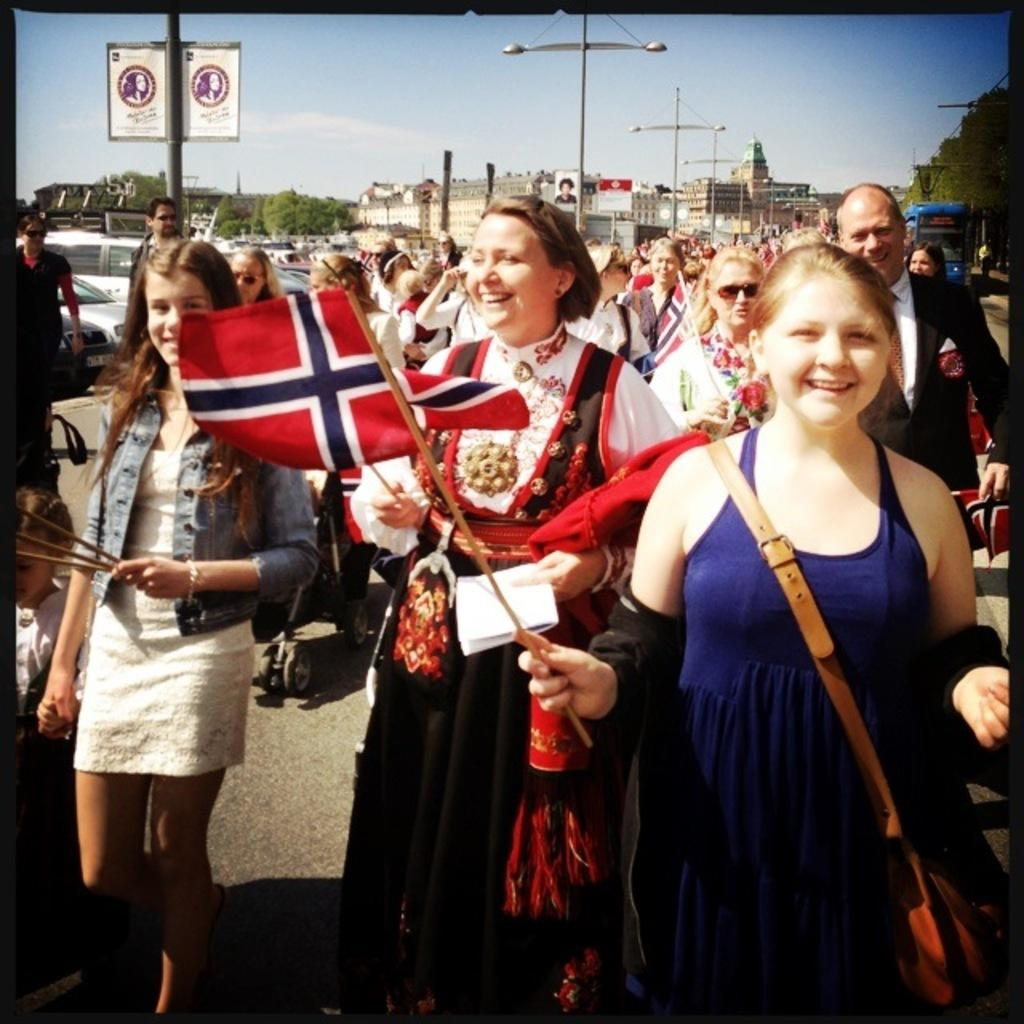What are the people in the image doing? The people in the image are standing on a road and holding flags. What else are the people holding in their hands? The people are also holding paper in their hands. What can be seen in the background of the image? There are trees, buildings, a bus, and the sky visible in the background of the image. How many people are swimming in the image? There are no people swimming in the image; they are standing on a road holding flags and paper. What nation are the people in the image representing? The image does not provide information about the nation the people are representing. 